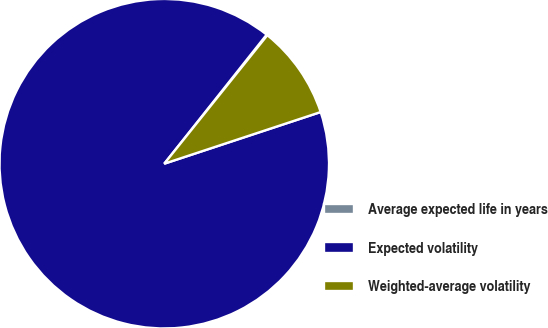<chart> <loc_0><loc_0><loc_500><loc_500><pie_chart><fcel>Average expected life in years<fcel>Expected volatility<fcel>Weighted-average volatility<nl><fcel>0.09%<fcel>90.75%<fcel>9.16%<nl></chart> 